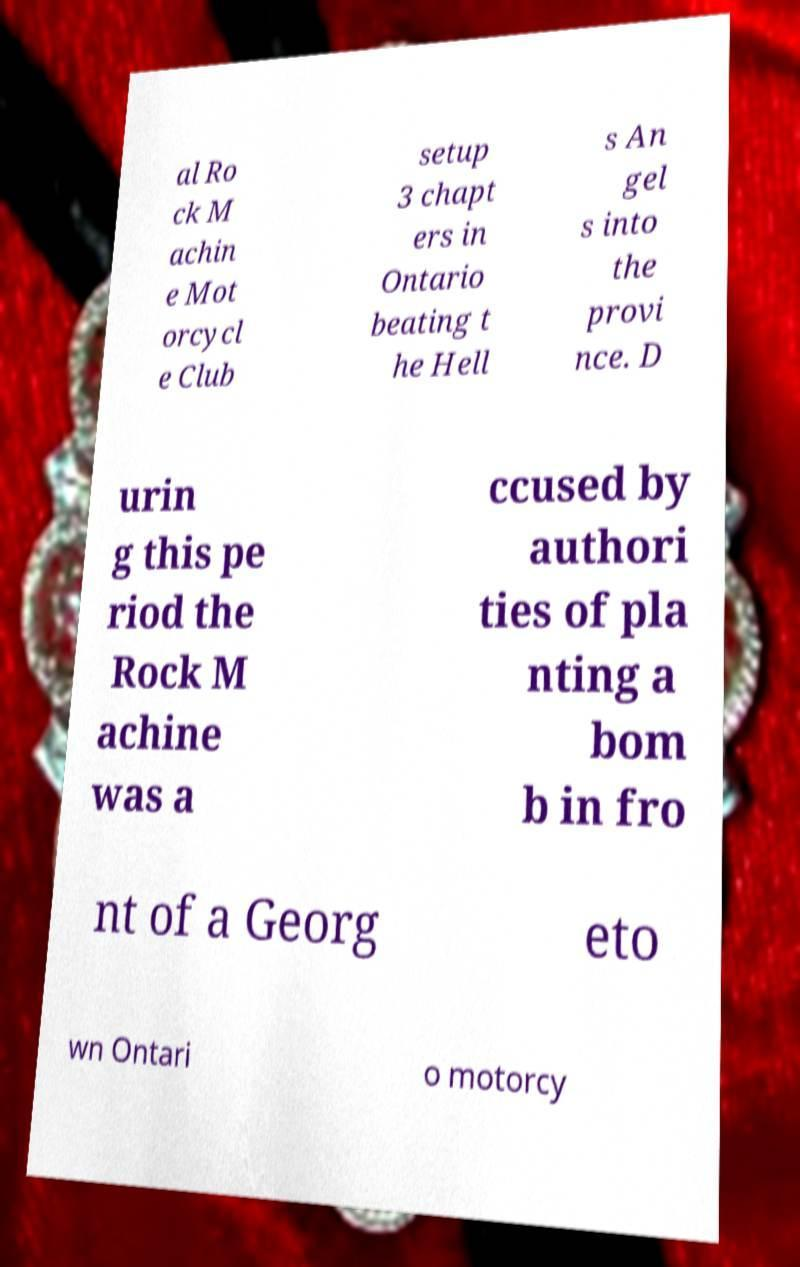There's text embedded in this image that I need extracted. Can you transcribe it verbatim? al Ro ck M achin e Mot orcycl e Club setup 3 chapt ers in Ontario beating t he Hell s An gel s into the provi nce. D urin g this pe riod the Rock M achine was a ccused by authori ties of pla nting a bom b in fro nt of a Georg eto wn Ontari o motorcy 